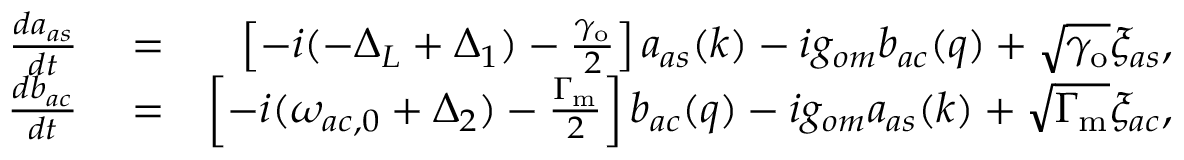<formula> <loc_0><loc_0><loc_500><loc_500>\begin{array} { r l r } { \frac { d a _ { a s } } { d t } } & = } & { \left [ - i ( - \Delta _ { L } + \Delta _ { 1 } ) - \frac { \gamma _ { o } } { 2 } \right ] a _ { a s } ( k ) - i g _ { o m } b _ { a c } ( q ) + \sqrt { \gamma _ { o } } \xi _ { a s } , } \\ { \frac { d b _ { a c } } { d t } } & = } & { \left [ - i ( \omega _ { a c , 0 } + \Delta _ { 2 } ) - \frac { \Gamma _ { m } } { 2 } \right ] b _ { a c } ( q ) - i g _ { o m } a _ { a s } ( k ) + \sqrt { \Gamma _ { m } } \xi _ { a c } , } \end{array}</formula> 